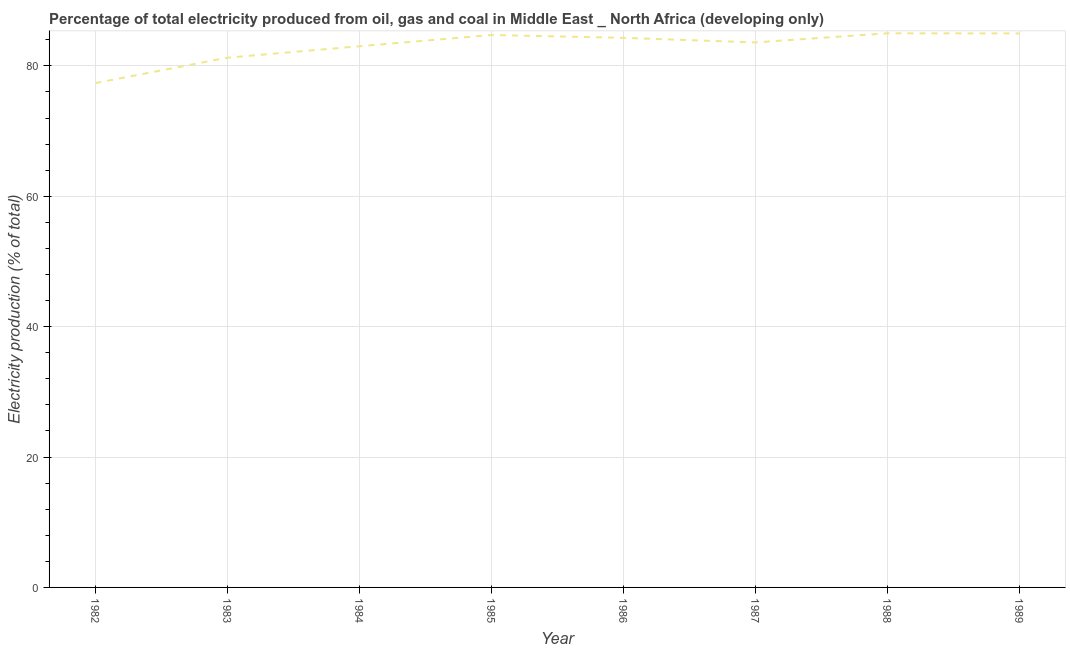What is the electricity production in 1982?
Make the answer very short. 77.36. Across all years, what is the maximum electricity production?
Keep it short and to the point. 84.99. Across all years, what is the minimum electricity production?
Ensure brevity in your answer.  77.36. In which year was the electricity production minimum?
Offer a terse response. 1982. What is the sum of the electricity production?
Your answer should be very brief. 664.23. What is the difference between the electricity production in 1984 and 1988?
Offer a terse response. -1.98. What is the average electricity production per year?
Your response must be concise. 83.03. What is the median electricity production?
Ensure brevity in your answer.  83.95. Do a majority of the years between 1983 and 1984 (inclusive) have electricity production greater than 40 %?
Your answer should be compact. Yes. What is the ratio of the electricity production in 1986 to that in 1987?
Give a very brief answer. 1.01. Is the electricity production in 1982 less than that in 1985?
Give a very brief answer. Yes. Is the difference between the electricity production in 1984 and 1989 greater than the difference between any two years?
Your answer should be very brief. No. What is the difference between the highest and the second highest electricity production?
Offer a very short reply. 0.02. What is the difference between the highest and the lowest electricity production?
Your answer should be compact. 7.64. In how many years, is the electricity production greater than the average electricity production taken over all years?
Your answer should be very brief. 5. How many lines are there?
Keep it short and to the point. 1. How many years are there in the graph?
Your answer should be very brief. 8. What is the difference between two consecutive major ticks on the Y-axis?
Your answer should be very brief. 20. Are the values on the major ticks of Y-axis written in scientific E-notation?
Offer a terse response. No. Does the graph contain any zero values?
Your response must be concise. No. What is the title of the graph?
Your answer should be compact. Percentage of total electricity produced from oil, gas and coal in Middle East _ North Africa (developing only). What is the label or title of the X-axis?
Your response must be concise. Year. What is the label or title of the Y-axis?
Make the answer very short. Electricity production (% of total). What is the Electricity production (% of total) of 1982?
Keep it short and to the point. 77.36. What is the Electricity production (% of total) of 1983?
Your answer should be compact. 81.25. What is the Electricity production (% of total) of 1984?
Offer a terse response. 83.01. What is the Electricity production (% of total) in 1985?
Your response must be concise. 84.73. What is the Electricity production (% of total) in 1986?
Provide a short and direct response. 84.3. What is the Electricity production (% of total) of 1987?
Your response must be concise. 83.6. What is the Electricity production (% of total) in 1988?
Your answer should be compact. 84.99. What is the Electricity production (% of total) in 1989?
Ensure brevity in your answer.  84.98. What is the difference between the Electricity production (% of total) in 1982 and 1983?
Give a very brief answer. -3.9. What is the difference between the Electricity production (% of total) in 1982 and 1984?
Provide a short and direct response. -5.65. What is the difference between the Electricity production (% of total) in 1982 and 1985?
Your response must be concise. -7.38. What is the difference between the Electricity production (% of total) in 1982 and 1986?
Make the answer very short. -6.94. What is the difference between the Electricity production (% of total) in 1982 and 1987?
Make the answer very short. -6.24. What is the difference between the Electricity production (% of total) in 1982 and 1988?
Ensure brevity in your answer.  -7.64. What is the difference between the Electricity production (% of total) in 1982 and 1989?
Offer a terse response. -7.62. What is the difference between the Electricity production (% of total) in 1983 and 1984?
Offer a terse response. -1.76. What is the difference between the Electricity production (% of total) in 1983 and 1985?
Your answer should be compact. -3.48. What is the difference between the Electricity production (% of total) in 1983 and 1986?
Provide a short and direct response. -3.05. What is the difference between the Electricity production (% of total) in 1983 and 1987?
Keep it short and to the point. -2.34. What is the difference between the Electricity production (% of total) in 1983 and 1988?
Your answer should be compact. -3.74. What is the difference between the Electricity production (% of total) in 1983 and 1989?
Give a very brief answer. -3.72. What is the difference between the Electricity production (% of total) in 1984 and 1985?
Keep it short and to the point. -1.72. What is the difference between the Electricity production (% of total) in 1984 and 1986?
Keep it short and to the point. -1.29. What is the difference between the Electricity production (% of total) in 1984 and 1987?
Ensure brevity in your answer.  -0.59. What is the difference between the Electricity production (% of total) in 1984 and 1988?
Ensure brevity in your answer.  -1.98. What is the difference between the Electricity production (% of total) in 1984 and 1989?
Give a very brief answer. -1.97. What is the difference between the Electricity production (% of total) in 1985 and 1986?
Your response must be concise. 0.43. What is the difference between the Electricity production (% of total) in 1985 and 1987?
Give a very brief answer. 1.13. What is the difference between the Electricity production (% of total) in 1985 and 1988?
Your answer should be compact. -0.26. What is the difference between the Electricity production (% of total) in 1985 and 1989?
Your answer should be compact. -0.24. What is the difference between the Electricity production (% of total) in 1986 and 1987?
Give a very brief answer. 0.7. What is the difference between the Electricity production (% of total) in 1986 and 1988?
Provide a succinct answer. -0.69. What is the difference between the Electricity production (% of total) in 1986 and 1989?
Provide a short and direct response. -0.68. What is the difference between the Electricity production (% of total) in 1987 and 1988?
Your answer should be compact. -1.4. What is the difference between the Electricity production (% of total) in 1987 and 1989?
Ensure brevity in your answer.  -1.38. What is the difference between the Electricity production (% of total) in 1988 and 1989?
Provide a short and direct response. 0.02. What is the ratio of the Electricity production (% of total) in 1982 to that in 1983?
Your answer should be compact. 0.95. What is the ratio of the Electricity production (% of total) in 1982 to that in 1984?
Your response must be concise. 0.93. What is the ratio of the Electricity production (% of total) in 1982 to that in 1985?
Your answer should be compact. 0.91. What is the ratio of the Electricity production (% of total) in 1982 to that in 1986?
Make the answer very short. 0.92. What is the ratio of the Electricity production (% of total) in 1982 to that in 1987?
Your answer should be very brief. 0.93. What is the ratio of the Electricity production (% of total) in 1982 to that in 1988?
Provide a short and direct response. 0.91. What is the ratio of the Electricity production (% of total) in 1982 to that in 1989?
Provide a succinct answer. 0.91. What is the ratio of the Electricity production (% of total) in 1983 to that in 1985?
Your response must be concise. 0.96. What is the ratio of the Electricity production (% of total) in 1983 to that in 1986?
Your response must be concise. 0.96. What is the ratio of the Electricity production (% of total) in 1983 to that in 1987?
Make the answer very short. 0.97. What is the ratio of the Electricity production (% of total) in 1983 to that in 1988?
Provide a short and direct response. 0.96. What is the ratio of the Electricity production (% of total) in 1983 to that in 1989?
Offer a terse response. 0.96. What is the ratio of the Electricity production (% of total) in 1985 to that in 1986?
Give a very brief answer. 1. What is the ratio of the Electricity production (% of total) in 1985 to that in 1989?
Provide a succinct answer. 1. What is the ratio of the Electricity production (% of total) in 1986 to that in 1987?
Ensure brevity in your answer.  1.01. What is the ratio of the Electricity production (% of total) in 1986 to that in 1988?
Keep it short and to the point. 0.99. What is the ratio of the Electricity production (% of total) in 1987 to that in 1989?
Provide a succinct answer. 0.98. What is the ratio of the Electricity production (% of total) in 1988 to that in 1989?
Give a very brief answer. 1. 